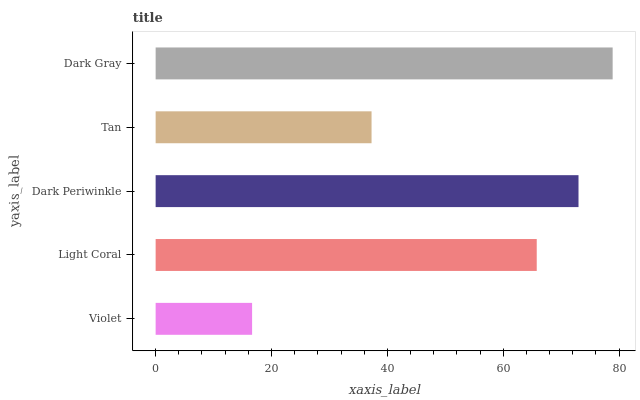Is Violet the minimum?
Answer yes or no. Yes. Is Dark Gray the maximum?
Answer yes or no. Yes. Is Light Coral the minimum?
Answer yes or no. No. Is Light Coral the maximum?
Answer yes or no. No. Is Light Coral greater than Violet?
Answer yes or no. Yes. Is Violet less than Light Coral?
Answer yes or no. Yes. Is Violet greater than Light Coral?
Answer yes or no. No. Is Light Coral less than Violet?
Answer yes or no. No. Is Light Coral the high median?
Answer yes or no. Yes. Is Light Coral the low median?
Answer yes or no. Yes. Is Violet the high median?
Answer yes or no. No. Is Dark Periwinkle the low median?
Answer yes or no. No. 